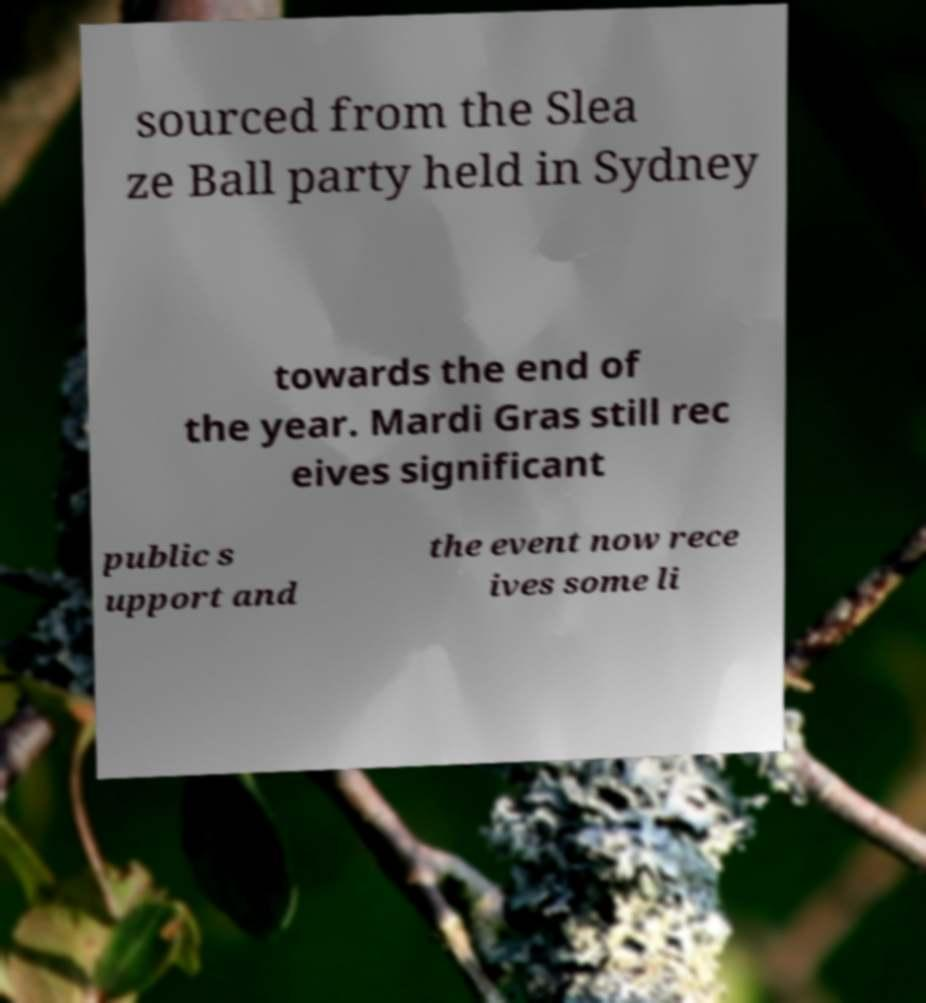There's text embedded in this image that I need extracted. Can you transcribe it verbatim? sourced from the Slea ze Ball party held in Sydney towards the end of the year. Mardi Gras still rec eives significant public s upport and the event now rece ives some li 